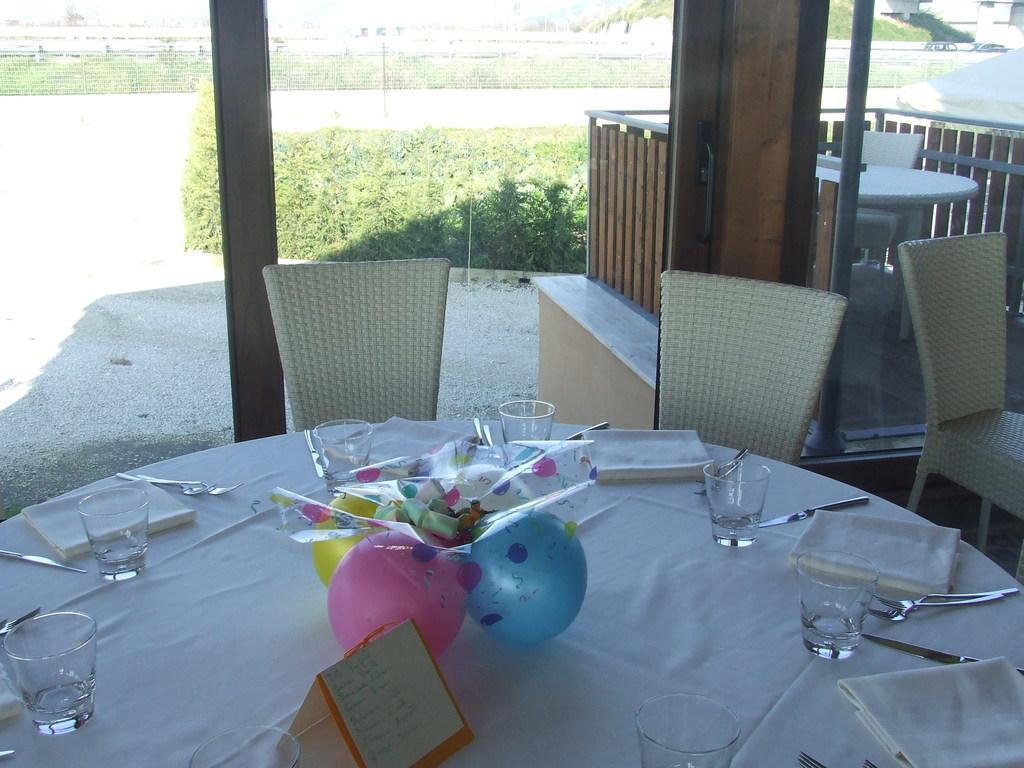Can you describe this image briefly? In this image i can see table on which there is a table cloth, a board,few glasses,few spoons, few forks, few knives, few clothes and few balloons. I can see chairs around the table. In the background you can see the glass through which I can see few plants, the railing and few buildings. 